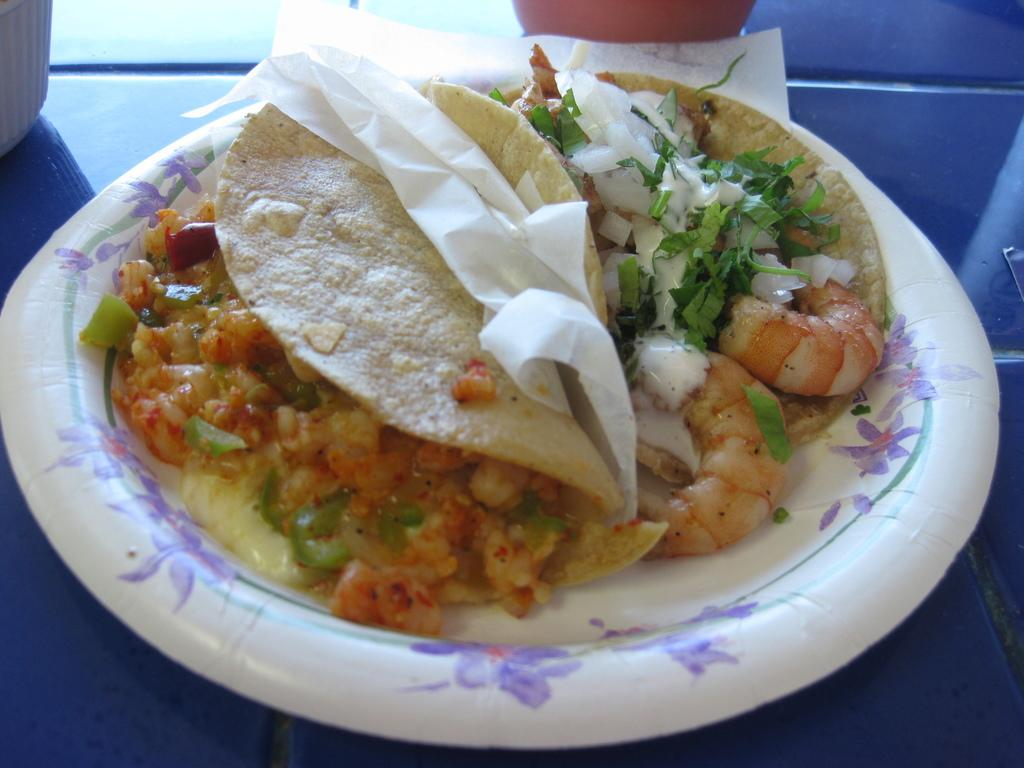What is on the plate in the image? There is food on a plate in the image. What else is on the plate besides the food? There is tissue on the plate. What color is the surface the plate is placed on? The plate is placed on a blue surface. Can you describe the unspecified objects at the top of the image? Unfortunately, the facts provided do not give any details about the unspecified objects at the top of the image. What type of company is depicted in the image? There is no company depicted in the image; it features a plate with food and tissue on a blue surface. Is there any blood visible in the image? No, there is no blood visible in the image. 